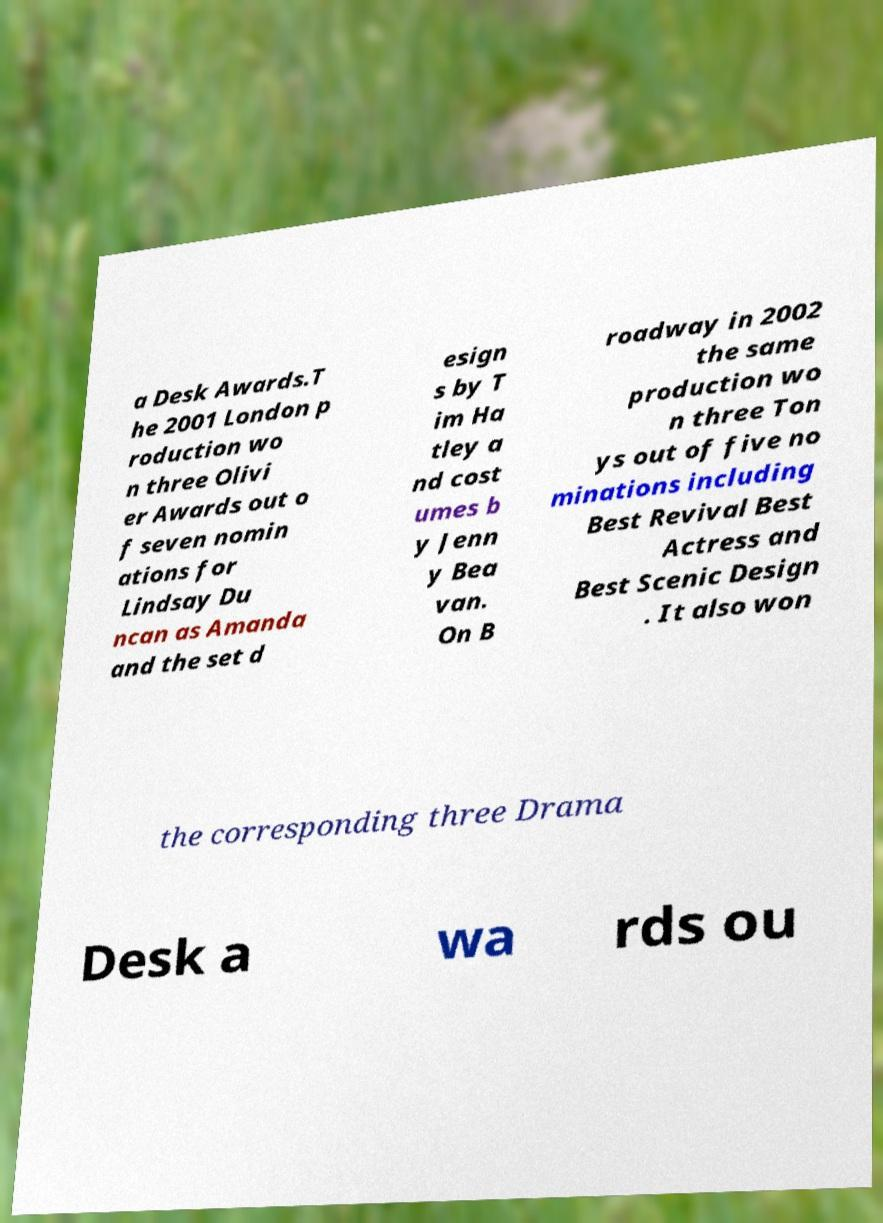I need the written content from this picture converted into text. Can you do that? a Desk Awards.T he 2001 London p roduction wo n three Olivi er Awards out o f seven nomin ations for Lindsay Du ncan as Amanda and the set d esign s by T im Ha tley a nd cost umes b y Jenn y Bea van. On B roadway in 2002 the same production wo n three Ton ys out of five no minations including Best Revival Best Actress and Best Scenic Design . It also won the corresponding three Drama Desk a wa rds ou 